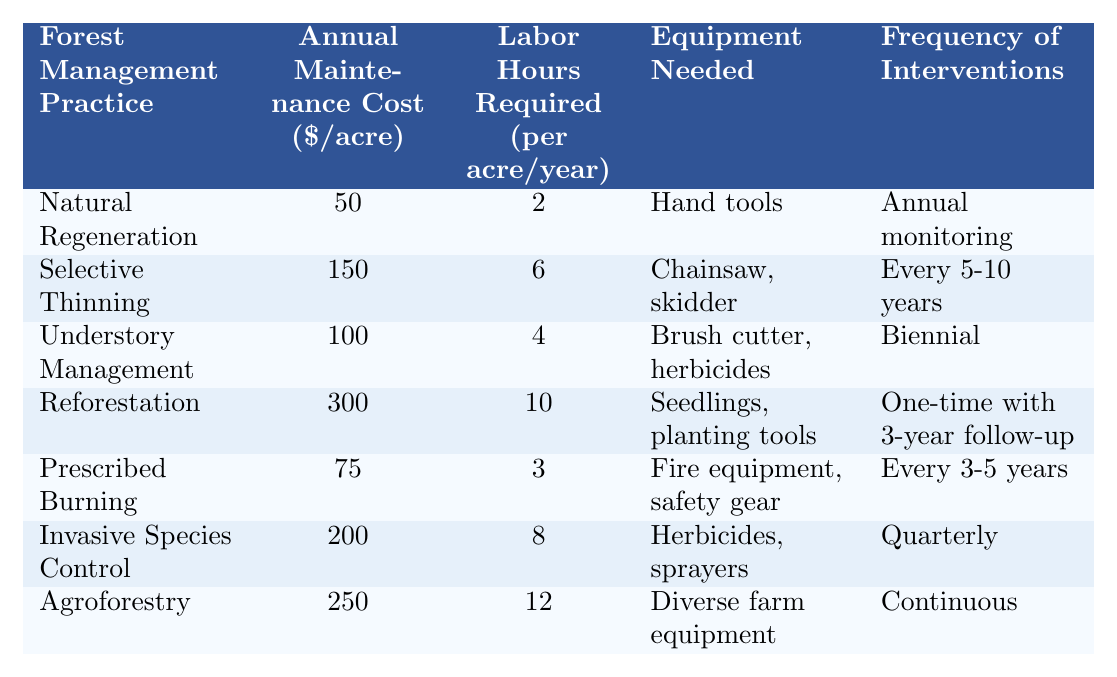What is the annual maintenance cost for Natural Regeneration? The table lists the annual maintenance cost for Natural Regeneration as $50 per acre.
Answer: $50 How many labor hours are required for Understory Management? According to the table, Understory Management requires 4 labor hours per acre per year.
Answer: 4 hours Which forest management practice requires the most labor hours? By comparing the labor hours for each practice, Agroforestry requires the most at 12 hours per acre per year.
Answer: Agroforestry What equipment is needed for Invasive Species Control? The table specifies that Invasive Species Control requires herbicides and sprayers.
Answer: Herbicides, sprayers How often do you need to carry out Selective Thinning interventions? The table indicates that Selective Thinning interventions are needed every 5-10 years.
Answer: Every 5-10 years What is the total annual maintenance cost for Natural Regeneration and Prescribed Burning combined? The cost for Natural Regeneration is $50 and for Prescribed Burning is $75, summing them gives $50 + $75 = $125.
Answer: $125 Is the annual maintenance cost for Reforestation higher than for Selective Thinning? Reforestation costs $300 while Selective Thinning costs $150, thus Reforestation is higher.
Answer: Yes Which forest management practice has the highest annual maintenance cost and how much is it? The highest cost is for Reforestation at $300 per acre per year.
Answer: Reforestation, $300 What is the difference in labor hours required between Agroforestry and Natural Regeneration? Agroforestry requires 12 hours while Natural Regeneration requires 2 hours, thus the difference is 12 - 2 = 10 hours.
Answer: 10 hours If you implement all practices, what would be the total annual maintenance cost? The total cost is $50 (Natural Regeneration) + $150 (Selective Thinning) + $100 (Understory Management) + $300 (Reforestation) + $75 (Prescribed Burning) + $200 (Invasive Species Control) + $250 (Agroforestry) = $1,125.
Answer: $1,125 